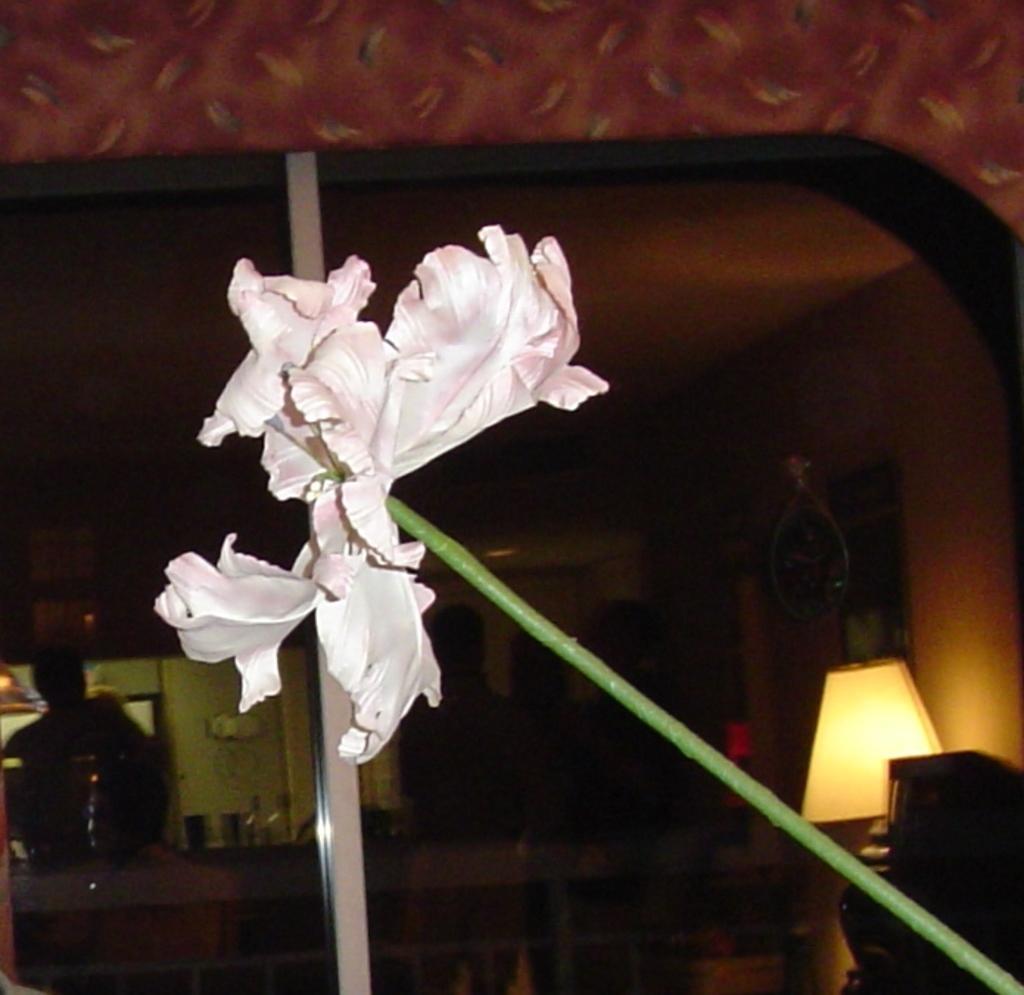Please provide a concise description of this image. In this image we can see a flower and we can see a lamp and some other objects on the right side of the image and in the background, we can see a few people and some other things. 